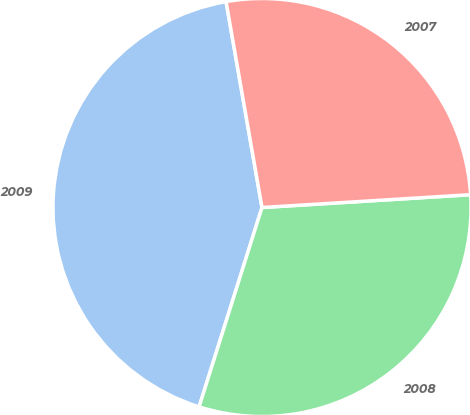Convert chart to OTSL. <chart><loc_0><loc_0><loc_500><loc_500><pie_chart><fcel>2009<fcel>2008<fcel>2007<nl><fcel>42.38%<fcel>30.84%<fcel>26.77%<nl></chart> 